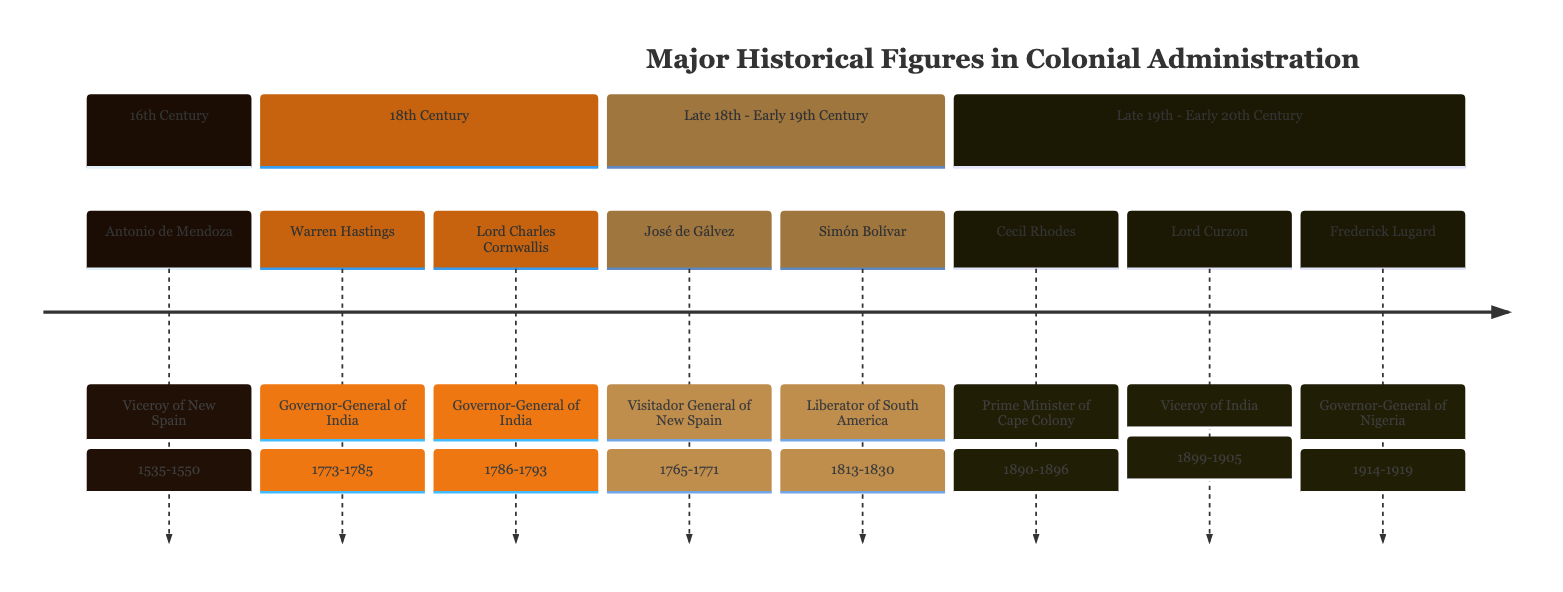What were the tenures of Warren Hastings and Lord Charles Cornwallis? Warren Hastings served from 1773 to 1785 and Lord Charles Cornwallis from 1786 to 1793, as shown in the timeline.
Answer: 1773-1785; 1786-1793 Which figure had the longest tenure in the list? The tenure of Antonio de Mendoza as Viceroy of New Spain from 1535 to 1550 lasted 15 years, which is the longest among the figures listed.
Answer: 15 years Who was the first viceroy of New Spain? The diagram identifies Antonio de Mendoza as the first Viceroy of New Spain, noted for establishing colonial administration during his tenure.
Answer: Antonio de Mendoza How many significant figures are listed in the timeline? By counting the nodes represented in the timeline, there are a total of 8 significant figures in the colonial administration context.
Answer: 8 What was the primary achievement of Frederick Lugard during his tenure? The timeline notes that Frederick Lugard is credited with unifying Northern and Southern Nigeria and developing the indirect rule policy, which was crucial for the colony.
Answer: Unified Northern and Southern Nigeria In which century did José de Gálvez serve as Visitador General of New Spain? The timeline places José de Gálvez's tenure from 1765 to 1771 in the late 18th century.
Answer: 18th century Which governor-general of India undertook large infrastructure projects? According to the timeline, Lord Curzon, serving as Viceroy from 1899 to 1905, is noted for undertaking large infrastructure projects in India.
Answer: Lord Curzon What was the main contribution of Lord Charles Cornwallis during his term? The timeline highlights that Lord Charles Cornwallis implemented economic reforms and founded the Cornwallis Code, impacting land revenue and judicial systems.
Answer: Economic reforms, Cornwallis Code 